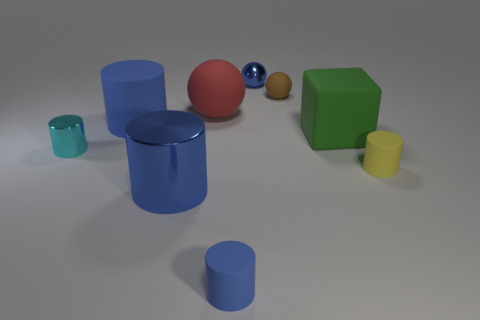Subtract all blue blocks. How many blue cylinders are left? 3 Subtract all yellow cylinders. How many cylinders are left? 4 Subtract 1 cylinders. How many cylinders are left? 4 Subtract all tiny blue cylinders. How many cylinders are left? 4 Subtract all purple cylinders. Subtract all blue cubes. How many cylinders are left? 5 Subtract all spheres. How many objects are left? 6 Add 1 big matte balls. How many objects exist? 10 Add 7 tiny purple rubber cylinders. How many tiny purple rubber cylinders exist? 7 Subtract 0 yellow blocks. How many objects are left? 9 Subtract all cyan cylinders. Subtract all tiny yellow metallic cylinders. How many objects are left? 8 